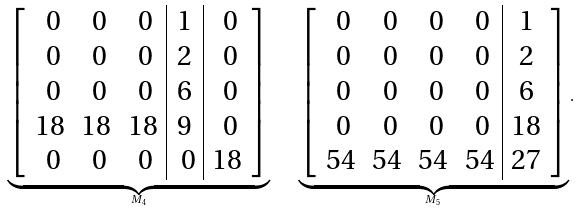Convert formula to latex. <formula><loc_0><loc_0><loc_500><loc_500>\underbrace { \left [ \begin{array} { c c c | c | c } \ 0 & \ 0 & \ 0 & 1 & \ 0 \\ \ 0 & \ 0 & \ 0 & 2 & \ 0 \\ \ 0 & \ 0 & \ 0 & 6 & \ 0 \\ 1 8 & 1 8 & 1 8 & 9 & \ 0 \\ \ 0 & \ 0 & \ 0 & \ 0 & 1 8 \end{array} \right ] } _ { M _ { 4 } } \quad \underbrace { \left [ \begin{array} { c c c c | c } \ 0 & \ 0 & \ 0 & \ 0 & 1 \\ \ 0 & \ 0 & \ 0 & \ 0 & 2 \\ \ 0 & \ 0 & \ 0 & \ 0 & 6 \\ \ 0 & \ 0 & \ 0 & \ 0 & 1 8 \\ 5 4 & 5 4 & 5 4 & 5 4 & 2 7 \end{array} \right ] } _ { M _ { 5 } } .</formula> 